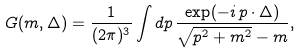Convert formula to latex. <formula><loc_0><loc_0><loc_500><loc_500>G ( m , \Delta ) = \frac { 1 } { ( 2 \pi ) ^ { 3 } } \int d { p } \, \frac { \exp ( - i \, { p } \cdot { \Delta } ) } { \sqrt { p ^ { 2 } + m ^ { 2 } } - m } ,</formula> 